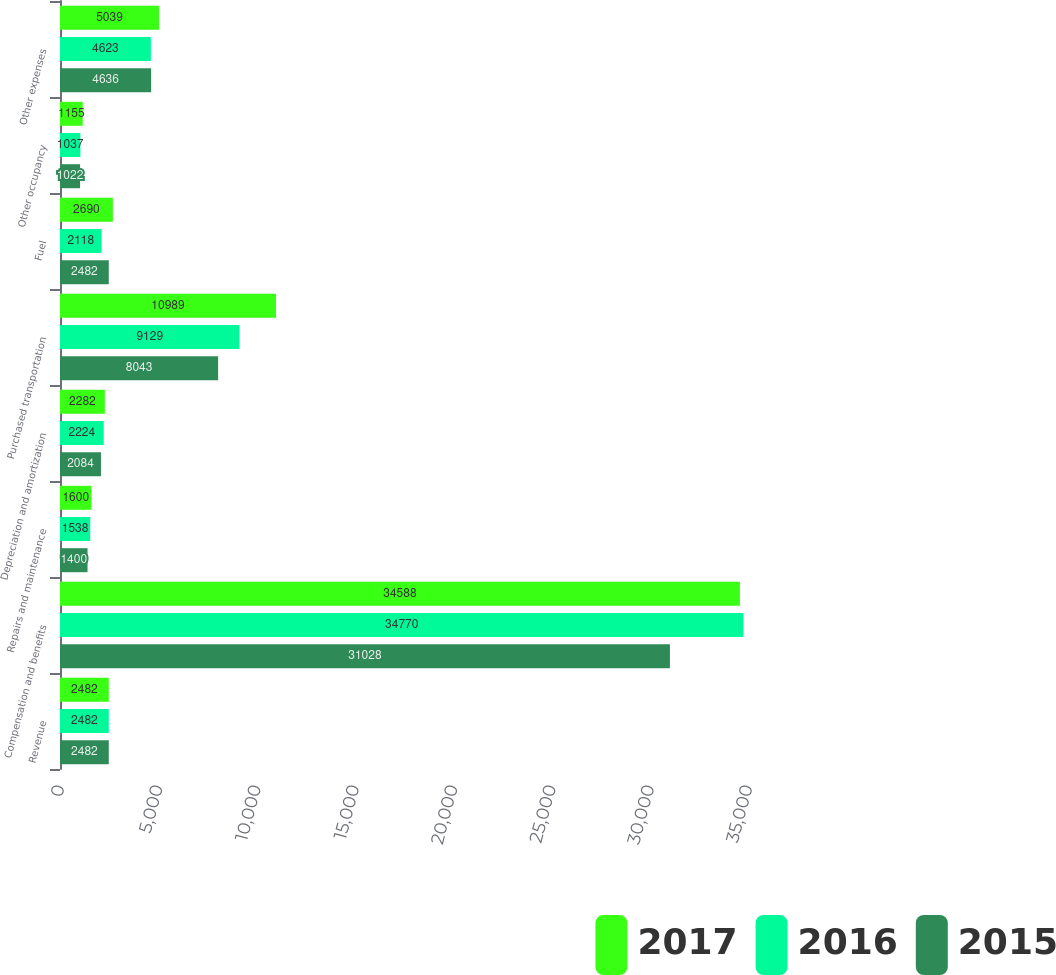Convert chart. <chart><loc_0><loc_0><loc_500><loc_500><stacked_bar_chart><ecel><fcel>Revenue<fcel>Compensation and benefits<fcel>Repairs and maintenance<fcel>Depreciation and amortization<fcel>Purchased transportation<fcel>Fuel<fcel>Other occupancy<fcel>Other expenses<nl><fcel>2017<fcel>2482<fcel>34588<fcel>1600<fcel>2282<fcel>10989<fcel>2690<fcel>1155<fcel>5039<nl><fcel>2016<fcel>2482<fcel>34770<fcel>1538<fcel>2224<fcel>9129<fcel>2118<fcel>1037<fcel>4623<nl><fcel>2015<fcel>2482<fcel>31028<fcel>1400<fcel>2084<fcel>8043<fcel>2482<fcel>1022<fcel>4636<nl></chart> 